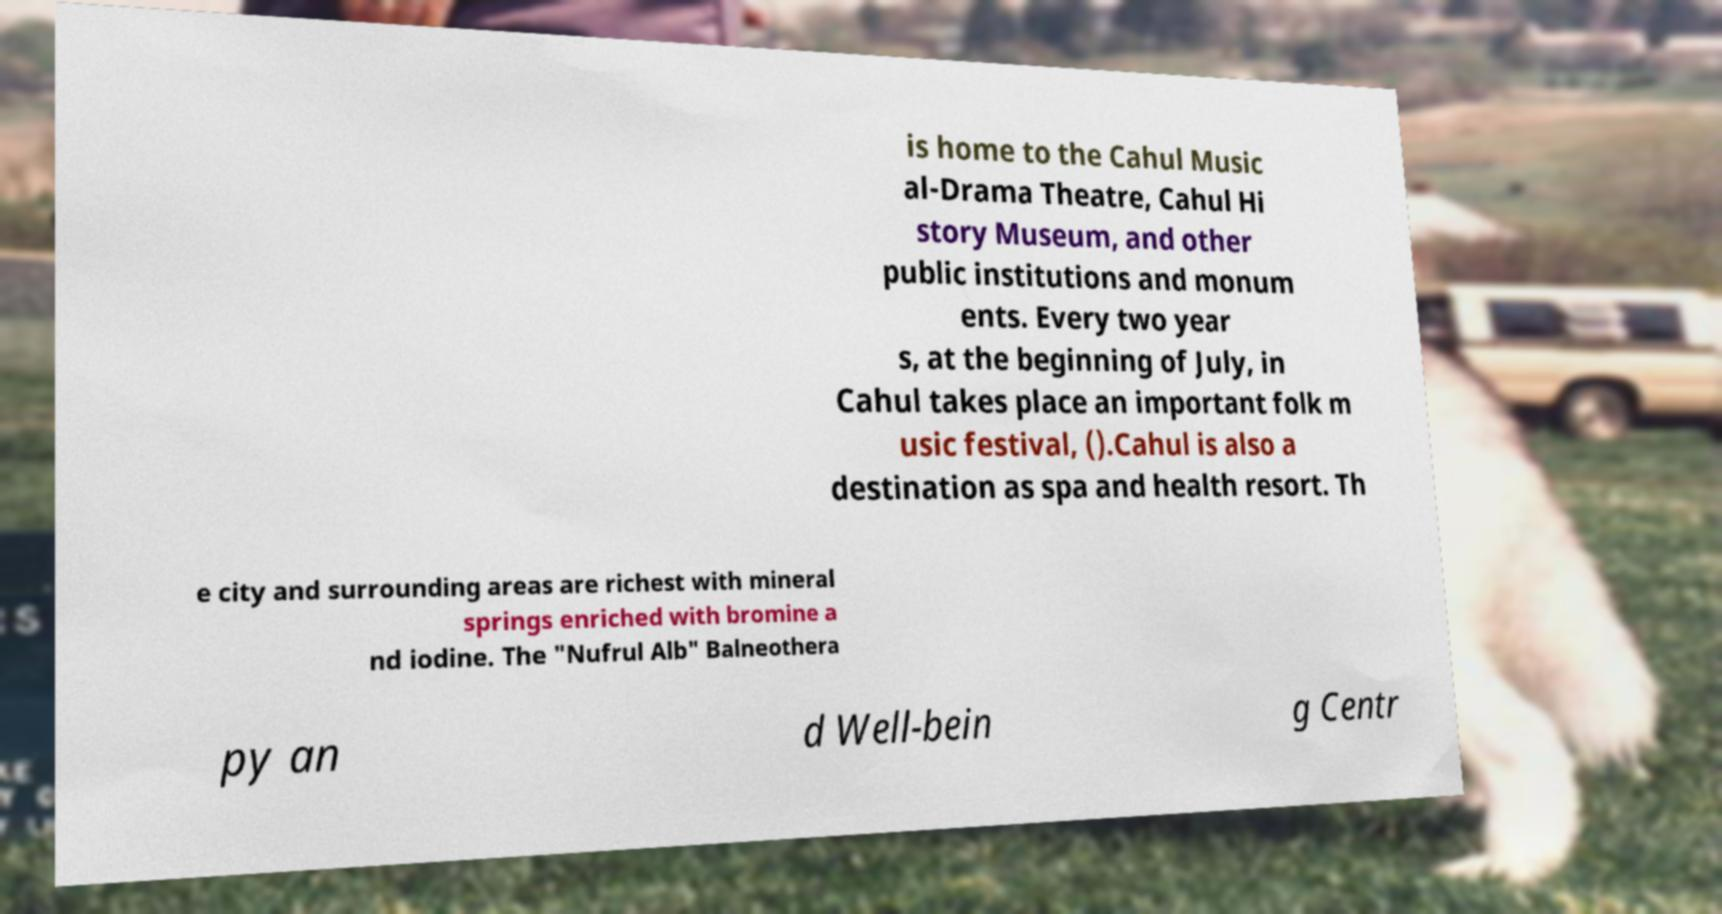I need the written content from this picture converted into text. Can you do that? is home to the Cahul Music al-Drama Theatre, Cahul Hi story Museum, and other public institutions and monum ents. Every two year s, at the beginning of July, in Cahul takes place an important folk m usic festival, ().Cahul is also a destination as spa and health resort. Th e city and surrounding areas are richest with mineral springs enriched with bromine a nd iodine. The "Nufrul Alb" Balneothera py an d Well-bein g Centr 